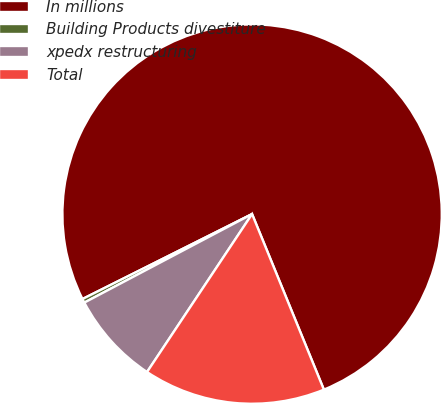Convert chart. <chart><loc_0><loc_0><loc_500><loc_500><pie_chart><fcel>In millions<fcel>Building Products divestiture<fcel>xpedx restructuring<fcel>Total<nl><fcel>76.22%<fcel>0.34%<fcel>7.93%<fcel>15.52%<nl></chart> 